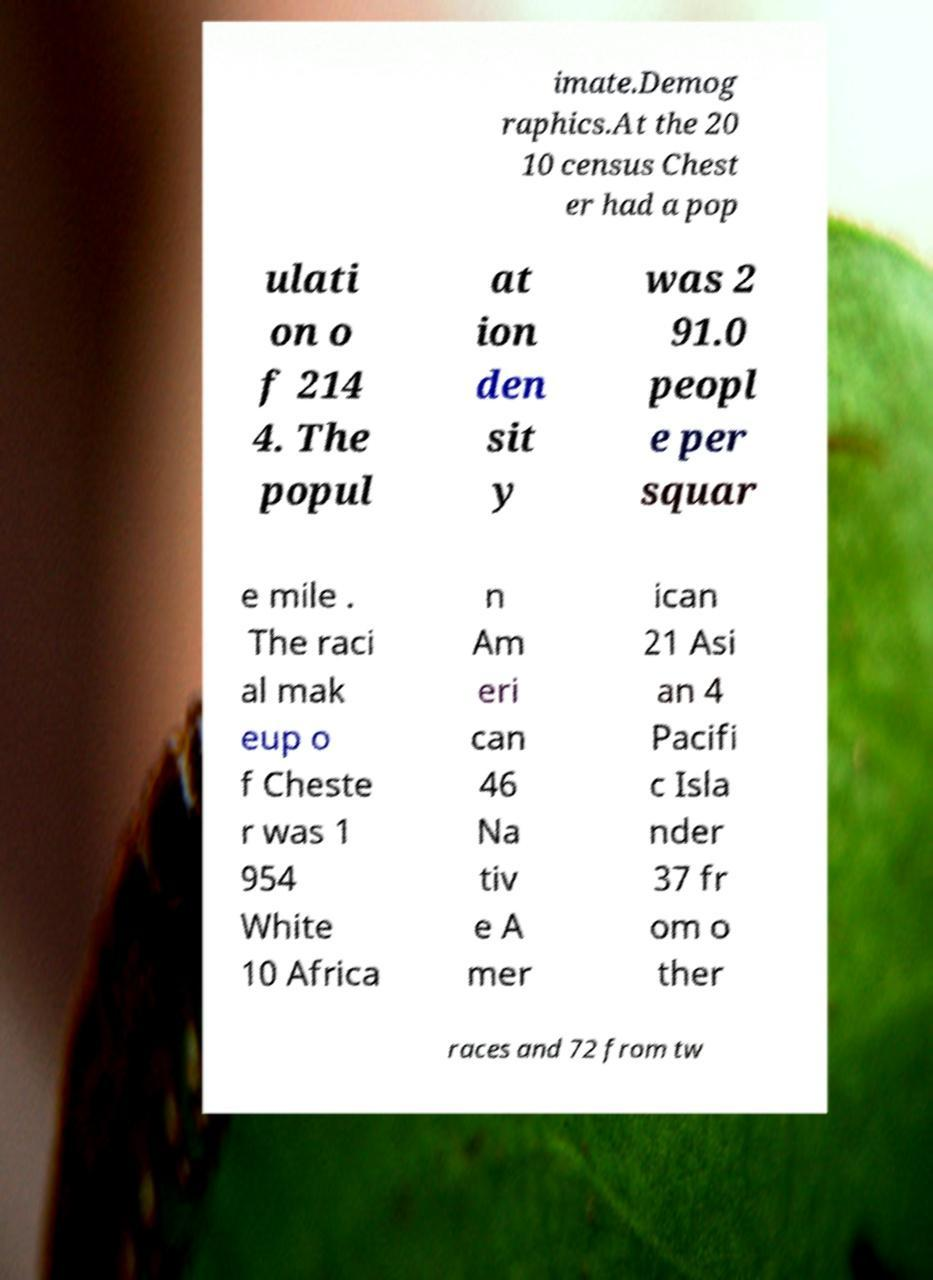Please read and relay the text visible in this image. What does it say? imate.Demog raphics.At the 20 10 census Chest er had a pop ulati on o f 214 4. The popul at ion den sit y was 2 91.0 peopl e per squar e mile . The raci al mak eup o f Cheste r was 1 954 White 10 Africa n Am eri can 46 Na tiv e A mer ican 21 Asi an 4 Pacifi c Isla nder 37 fr om o ther races and 72 from tw 